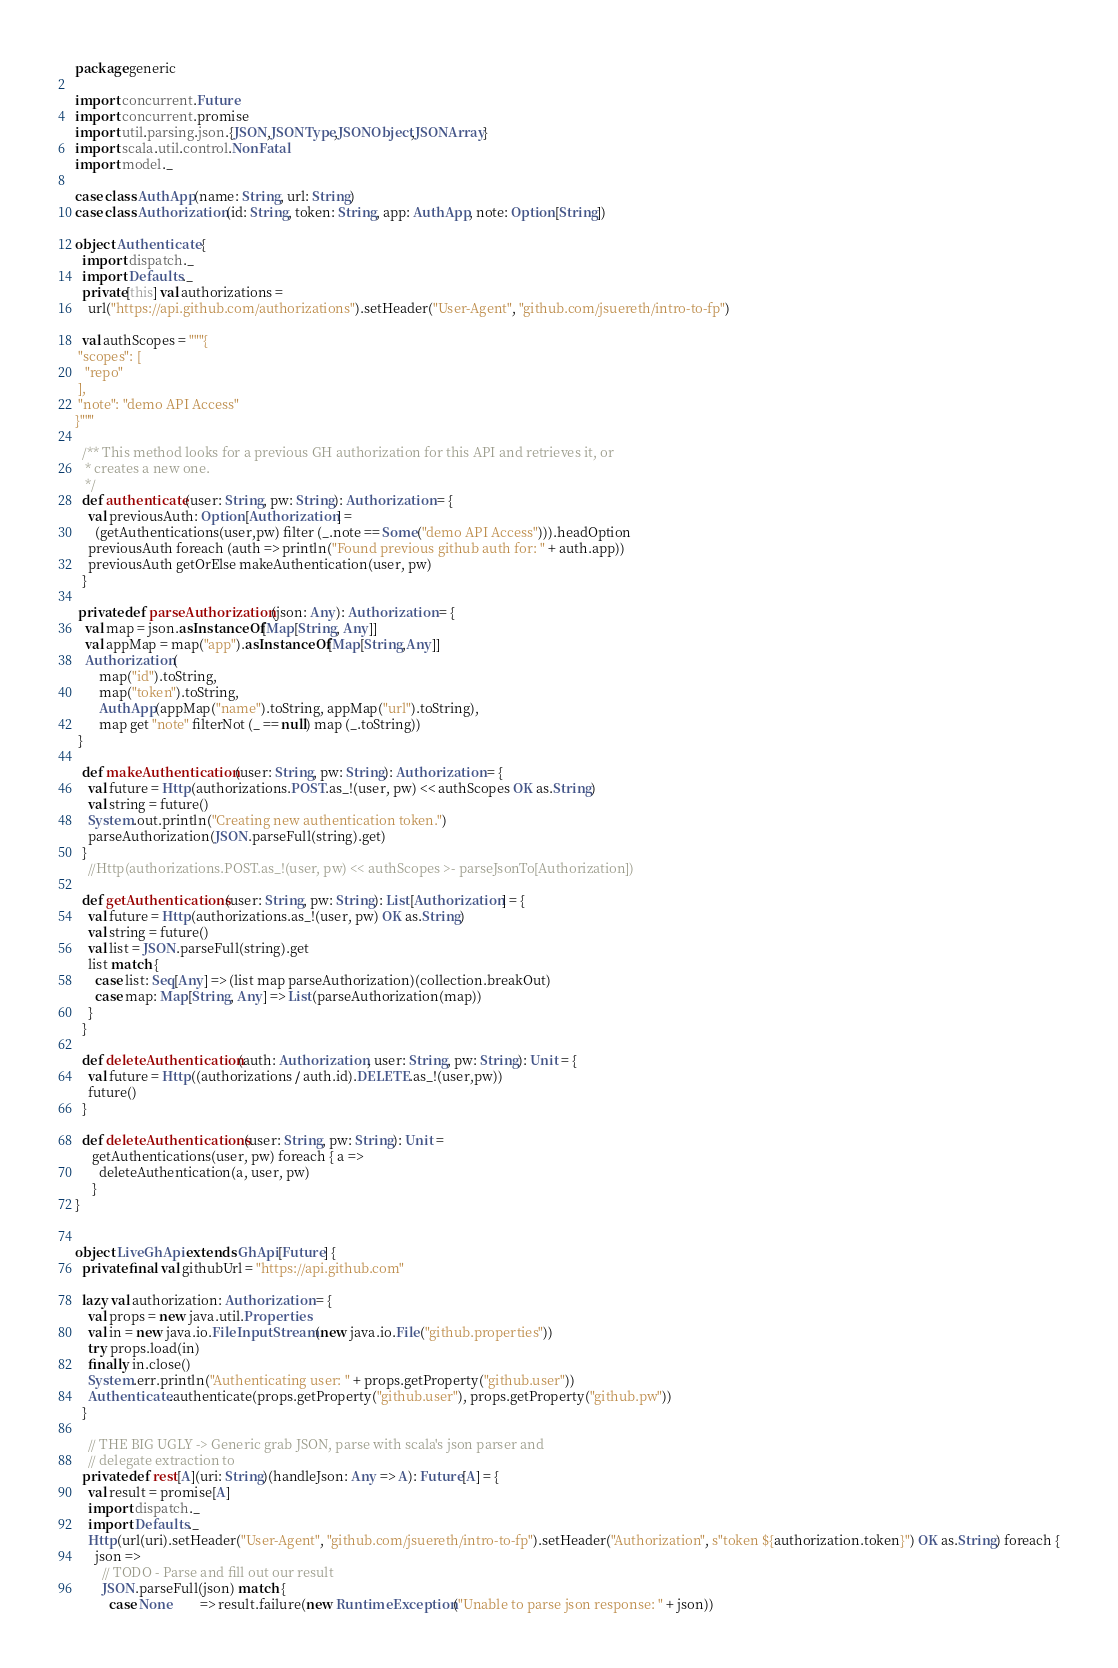Convert code to text. <code><loc_0><loc_0><loc_500><loc_500><_Scala_>package generic

import concurrent.Future
import concurrent.promise
import util.parsing.json.{JSON,JSONType,JSONObject,JSONArray}
import scala.util.control.NonFatal
import model._

case class AuthApp(name: String, url: String)
case class Authorization(id: String, token: String, app: AuthApp, note: Option[String])

object Authenticate {
  import dispatch._
  import Defaults._
  private[this] val authorizations = 
    url("https://api.github.com/authorizations").setHeader("User-Agent", "github.com/jsuereth/intro-to-fp")

  val authScopes = """{
 "scopes": [ 
   "repo"
 ],
 "note": "demo API Access"
}"""

  /** This method looks for a previous GH authorization for this API and retrieves it, or
   * creates a new one.
   */
  def authenticate(user: String, pw: String): Authorization = {
    val previousAuth: Option[Authorization] =
      (getAuthentications(user,pw) filter (_.note == Some("demo API Access"))).headOption
    previousAuth foreach (auth => println("Found previous github auth for: " + auth.app))
    previousAuth getOrElse makeAuthentication(user, pw)
  }

 private def parseAuthorization(json: Any): Authorization = {
   val map = json.asInstanceOf[Map[String, Any]]
   val appMap = map("app").asInstanceOf[Map[String,Any]]
   Authorization(
       map("id").toString,
       map("token").toString,
       AuthApp(appMap("name").toString, appMap("url").toString),
       map get "note" filterNot (_ == null) map (_.toString))
 }
  
  def makeAuthentication(user: String, pw: String): Authorization = {
    val future = Http(authorizations.POST.as_!(user, pw) << authScopes OK as.String)
    val string = future()
    System.out.println("Creating new authentication token.")
    parseAuthorization(JSON.parseFull(string).get)
  }
    //Http(authorizations.POST.as_!(user, pw) << authScopes >- parseJsonTo[Authorization])

  def getAuthentications(user: String, pw: String): List[Authorization] = {
    val future = Http(authorizations.as_!(user, pw) OK as.String)
    val string = future()
    val list = JSON.parseFull(string).get
    list match {
      case list: Seq[Any] => (list map parseAuthorization)(collection.breakOut)
      case map: Map[String, Any] => List(parseAuthorization(map))
    }
  }

  def deleteAuthentication(auth: Authorization, user: String, pw: String): Unit = {
    val future = Http((authorizations / auth.id).DELETE.as_!(user,pw))
    future()
  }

  def deleteAuthentications(user: String, pw: String): Unit =
     getAuthentications(user, pw) foreach { a => 
       deleteAuthentication(a, user, pw) 
     }
}


object LiveGhApi extends GhApi[Future] {
  private final val githubUrl = "https://api.github.com"

  lazy val authorization: Authorization = {
    val props = new java.util.Properties
    val in = new java.io.FileInputStream(new java.io.File("github.properties"))
    try props.load(in)
    finally in.close()
    System.err.println("Authenticating user: " + props.getProperty("github.user"))
    Authenticate.authenticate(props.getProperty("github.user"), props.getProperty("github.pw"))
  }
  
    // THE BIG UGLY -> Generic grab JSON, parse with scala's json parser and
    // delegate extraction to
  private def rest[A](uri: String)(handleJson: Any => A): Future[A] = {
    val result = promise[A]
    import dispatch._
    import Defaults._
    Http(url(uri).setHeader("User-Agent", "github.com/jsuereth/intro-to-fp").setHeader("Authorization", s"token ${authorization.token}") OK as.String) foreach {
      json =>
        // TODO - Parse and fill out our result
        JSON.parseFull(json) match {
          case None        => result.failure(new RuntimeException("Unable to parse json response: " + json))</code> 